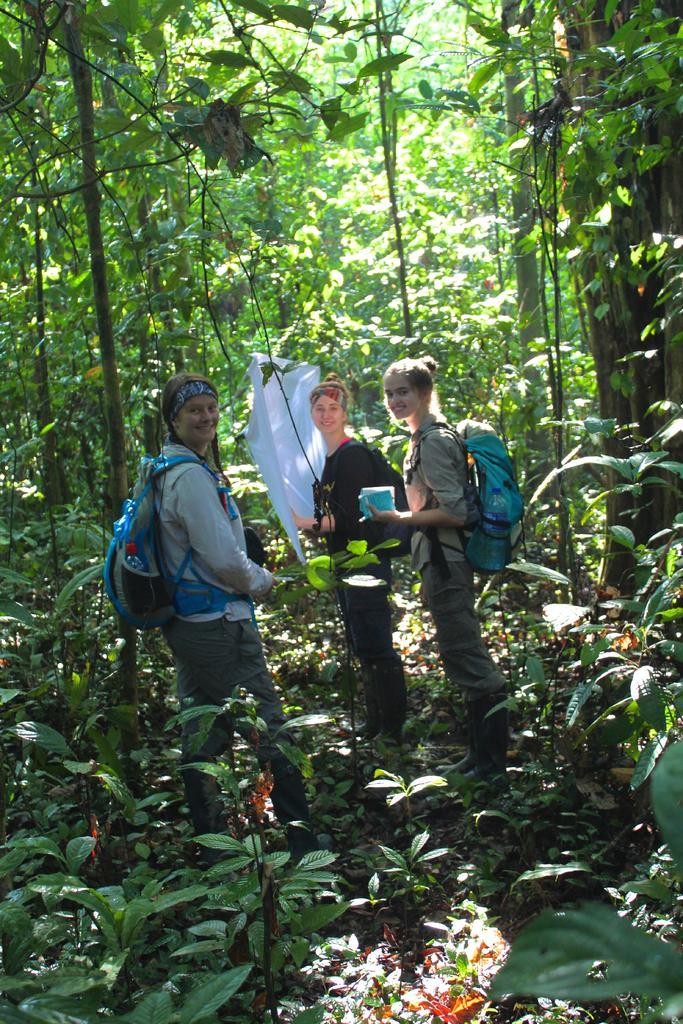In one or two sentences, can you explain what this image depicts? In the foreground of this image, there are three women standing wearing backpacks and holding few objects. Behind them, there is a white color cloth and around them, there are trees and plants. 